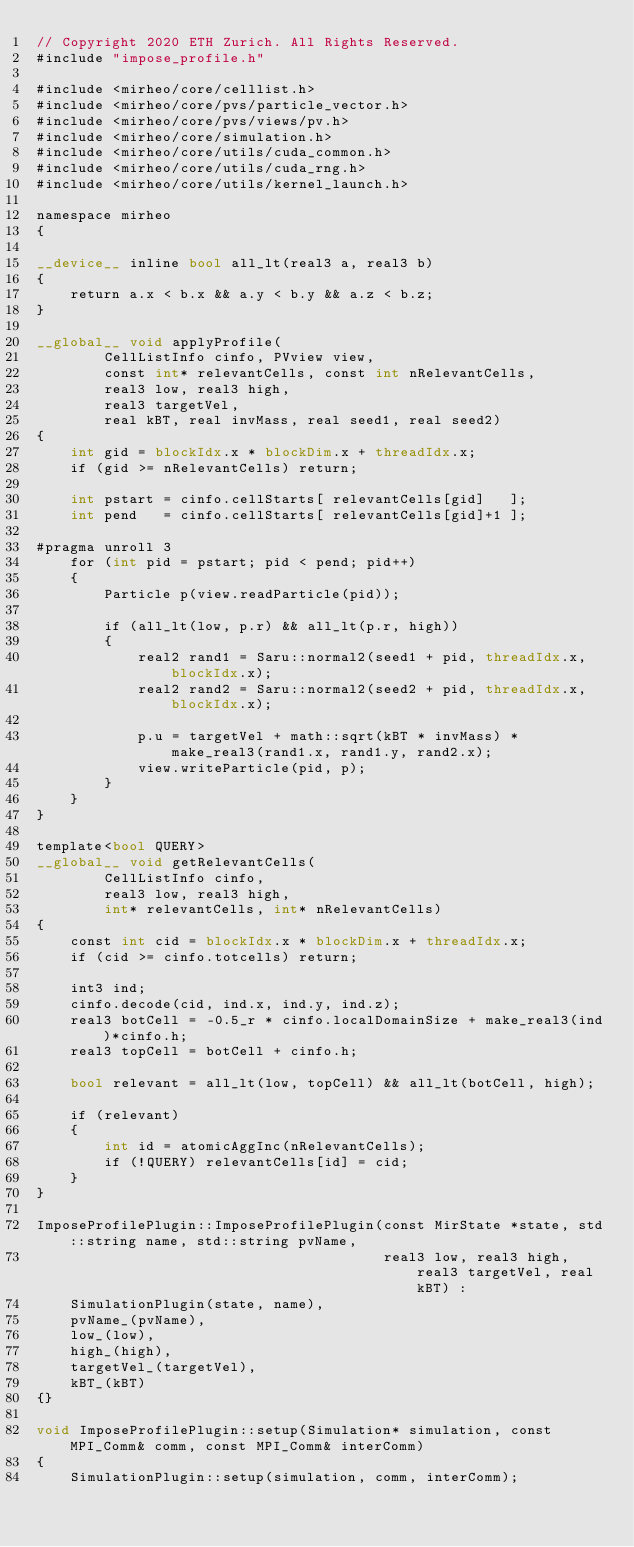Convert code to text. <code><loc_0><loc_0><loc_500><loc_500><_Cuda_>// Copyright 2020 ETH Zurich. All Rights Reserved.
#include "impose_profile.h"

#include <mirheo/core/celllist.h>
#include <mirheo/core/pvs/particle_vector.h>
#include <mirheo/core/pvs/views/pv.h>
#include <mirheo/core/simulation.h>
#include <mirheo/core/utils/cuda_common.h>
#include <mirheo/core/utils/cuda_rng.h>
#include <mirheo/core/utils/kernel_launch.h>

namespace mirheo
{

__device__ inline bool all_lt(real3 a, real3 b)
{
    return a.x < b.x && a.y < b.y && a.z < b.z;
}

__global__ void applyProfile(
        CellListInfo cinfo, PVview view,
        const int* relevantCells, const int nRelevantCells,
        real3 low, real3 high,
        real3 targetVel,
        real kBT, real invMass, real seed1, real seed2)
{
    int gid = blockIdx.x * blockDim.x + threadIdx.x;
    if (gid >= nRelevantCells) return;

    int pstart = cinfo.cellStarts[ relevantCells[gid]   ];
    int pend   = cinfo.cellStarts[ relevantCells[gid]+1 ];

#pragma unroll 3
    for (int pid = pstart; pid < pend; pid++)
    {
        Particle p(view.readParticle(pid));

        if (all_lt(low, p.r) && all_lt(p.r, high))
        {
            real2 rand1 = Saru::normal2(seed1 + pid, threadIdx.x, blockIdx.x);
            real2 rand2 = Saru::normal2(seed2 + pid, threadIdx.x, blockIdx.x);

            p.u = targetVel + math::sqrt(kBT * invMass) * make_real3(rand1.x, rand1.y, rand2.x);
            view.writeParticle(pid, p);
        }
    }
}

template<bool QUERY>
__global__ void getRelevantCells(
        CellListInfo cinfo,
        real3 low, real3 high,
        int* relevantCells, int* nRelevantCells)
{
    const int cid = blockIdx.x * blockDim.x + threadIdx.x;
    if (cid >= cinfo.totcells) return;

    int3 ind;
    cinfo.decode(cid, ind.x, ind.y, ind.z);
    real3 botCell = -0.5_r * cinfo.localDomainSize + make_real3(ind)*cinfo.h;
    real3 topCell = botCell + cinfo.h;

    bool relevant = all_lt(low, topCell) && all_lt(botCell, high);

    if (relevant)
    {
        int id = atomicAggInc(nRelevantCells);
        if (!QUERY) relevantCells[id] = cid;
    }
}

ImposeProfilePlugin::ImposeProfilePlugin(const MirState *state, std::string name, std::string pvName,
                                         real3 low, real3 high, real3 targetVel, real kBT) :
    SimulationPlugin(state, name),
    pvName_(pvName),
    low_(low),
    high_(high),
    targetVel_(targetVel),
    kBT_(kBT)
{}

void ImposeProfilePlugin::setup(Simulation* simulation, const MPI_Comm& comm, const MPI_Comm& interComm)
{
    SimulationPlugin::setup(simulation, comm, interComm);
</code> 